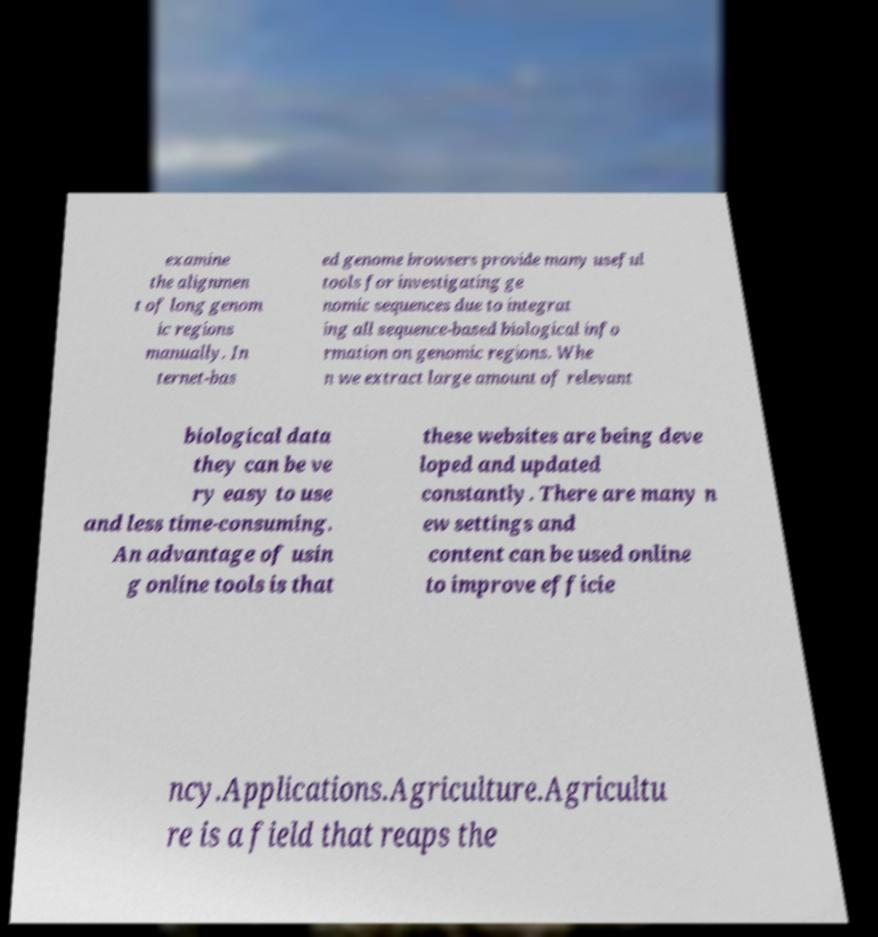Please identify and transcribe the text found in this image. examine the alignmen t of long genom ic regions manually. In ternet-bas ed genome browsers provide many useful tools for investigating ge nomic sequences due to integrat ing all sequence-based biological info rmation on genomic regions. Whe n we extract large amount of relevant biological data they can be ve ry easy to use and less time-consuming. An advantage of usin g online tools is that these websites are being deve loped and updated constantly. There are many n ew settings and content can be used online to improve efficie ncy.Applications.Agriculture.Agricultu re is a field that reaps the 